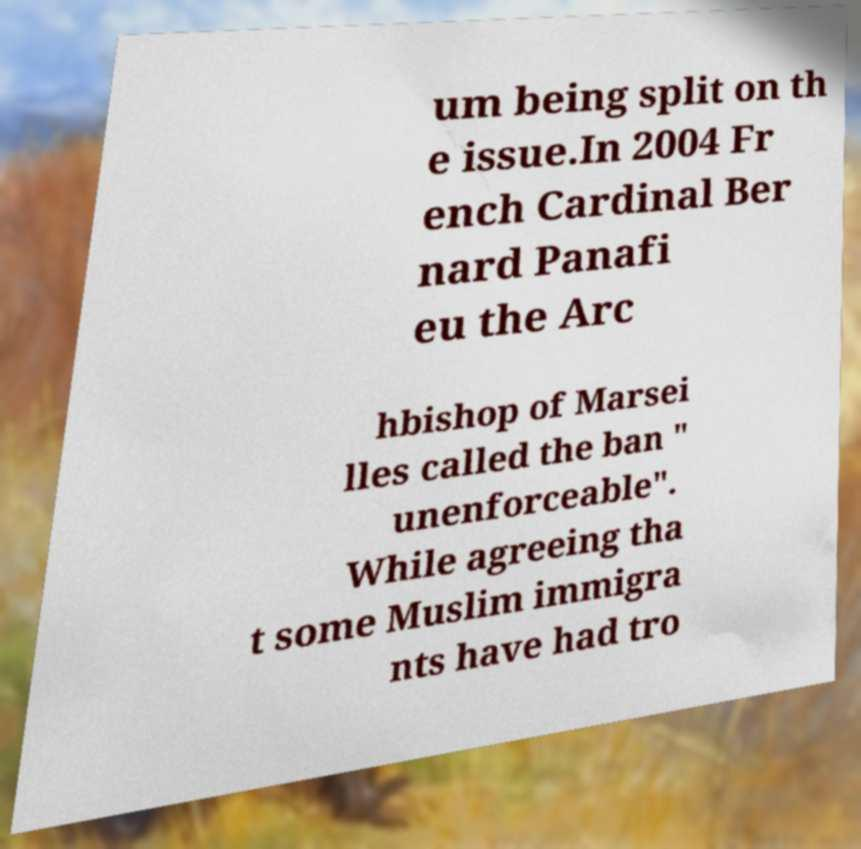Could you assist in decoding the text presented in this image and type it out clearly? um being split on th e issue.In 2004 Fr ench Cardinal Ber nard Panafi eu the Arc hbishop of Marsei lles called the ban " unenforceable". While agreeing tha t some Muslim immigra nts have had tro 